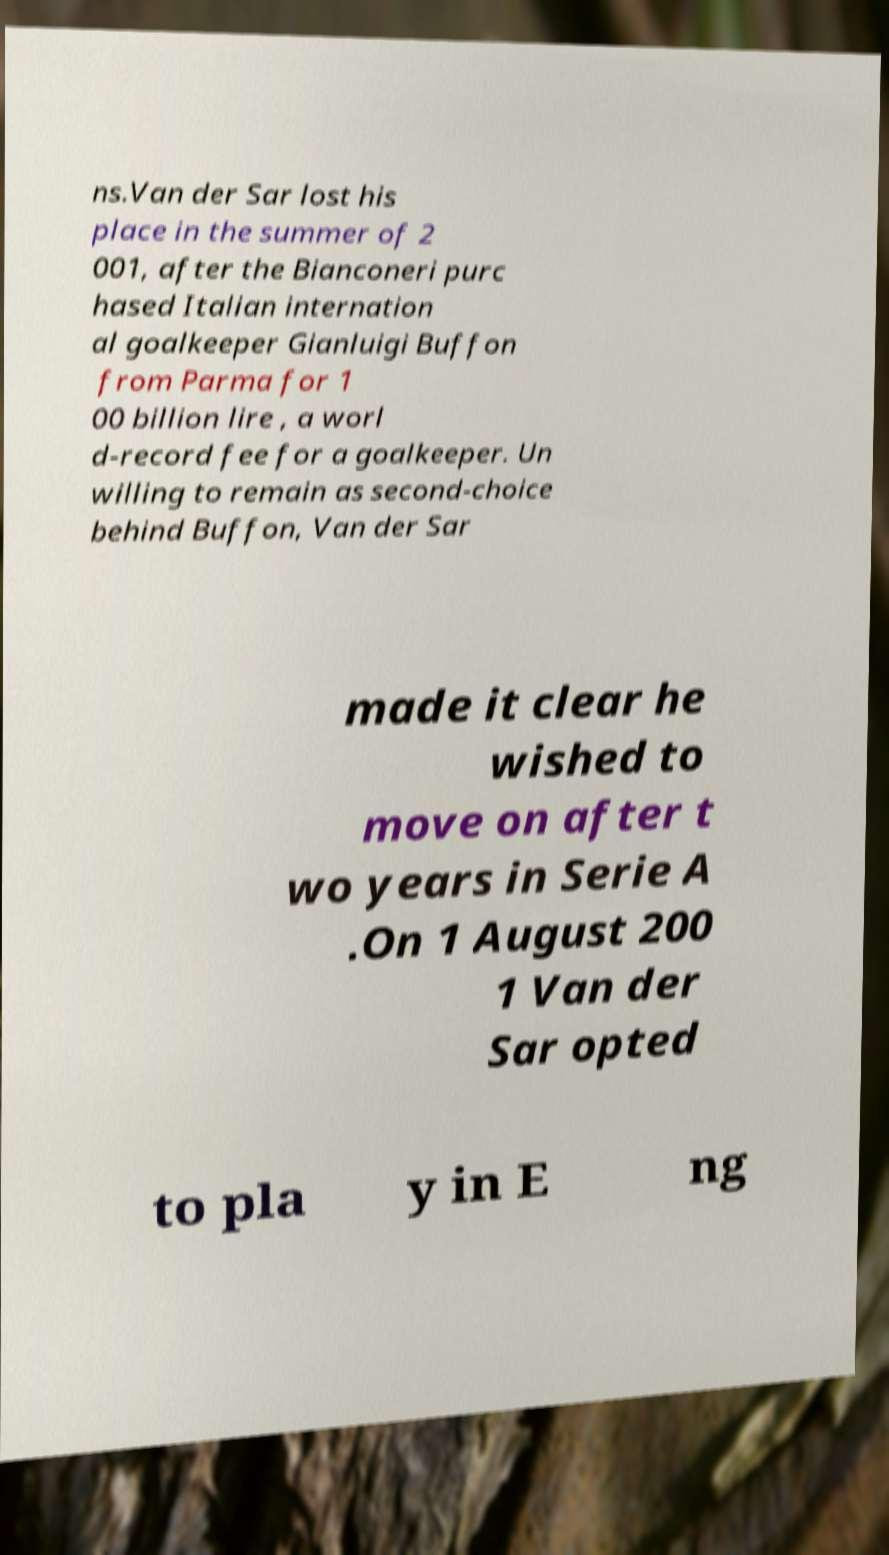Please identify and transcribe the text found in this image. ns.Van der Sar lost his place in the summer of 2 001, after the Bianconeri purc hased Italian internation al goalkeeper Gianluigi Buffon from Parma for 1 00 billion lire , a worl d-record fee for a goalkeeper. Un willing to remain as second-choice behind Buffon, Van der Sar made it clear he wished to move on after t wo years in Serie A .On 1 August 200 1 Van der Sar opted to pla y in E ng 